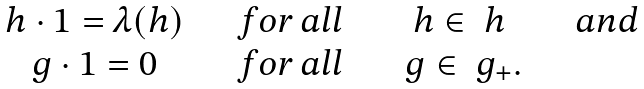Convert formula to latex. <formula><loc_0><loc_0><loc_500><loc_500>\begin{array} { c c c c } h \cdot 1 = \lambda ( h ) & \quad f o r \, a l l \quad & h \in \ h & \quad a n d \\ g \cdot 1 = 0 & \quad f o r \, a l l \quad & \ g \in \ g _ { + } . & \end{array}</formula> 